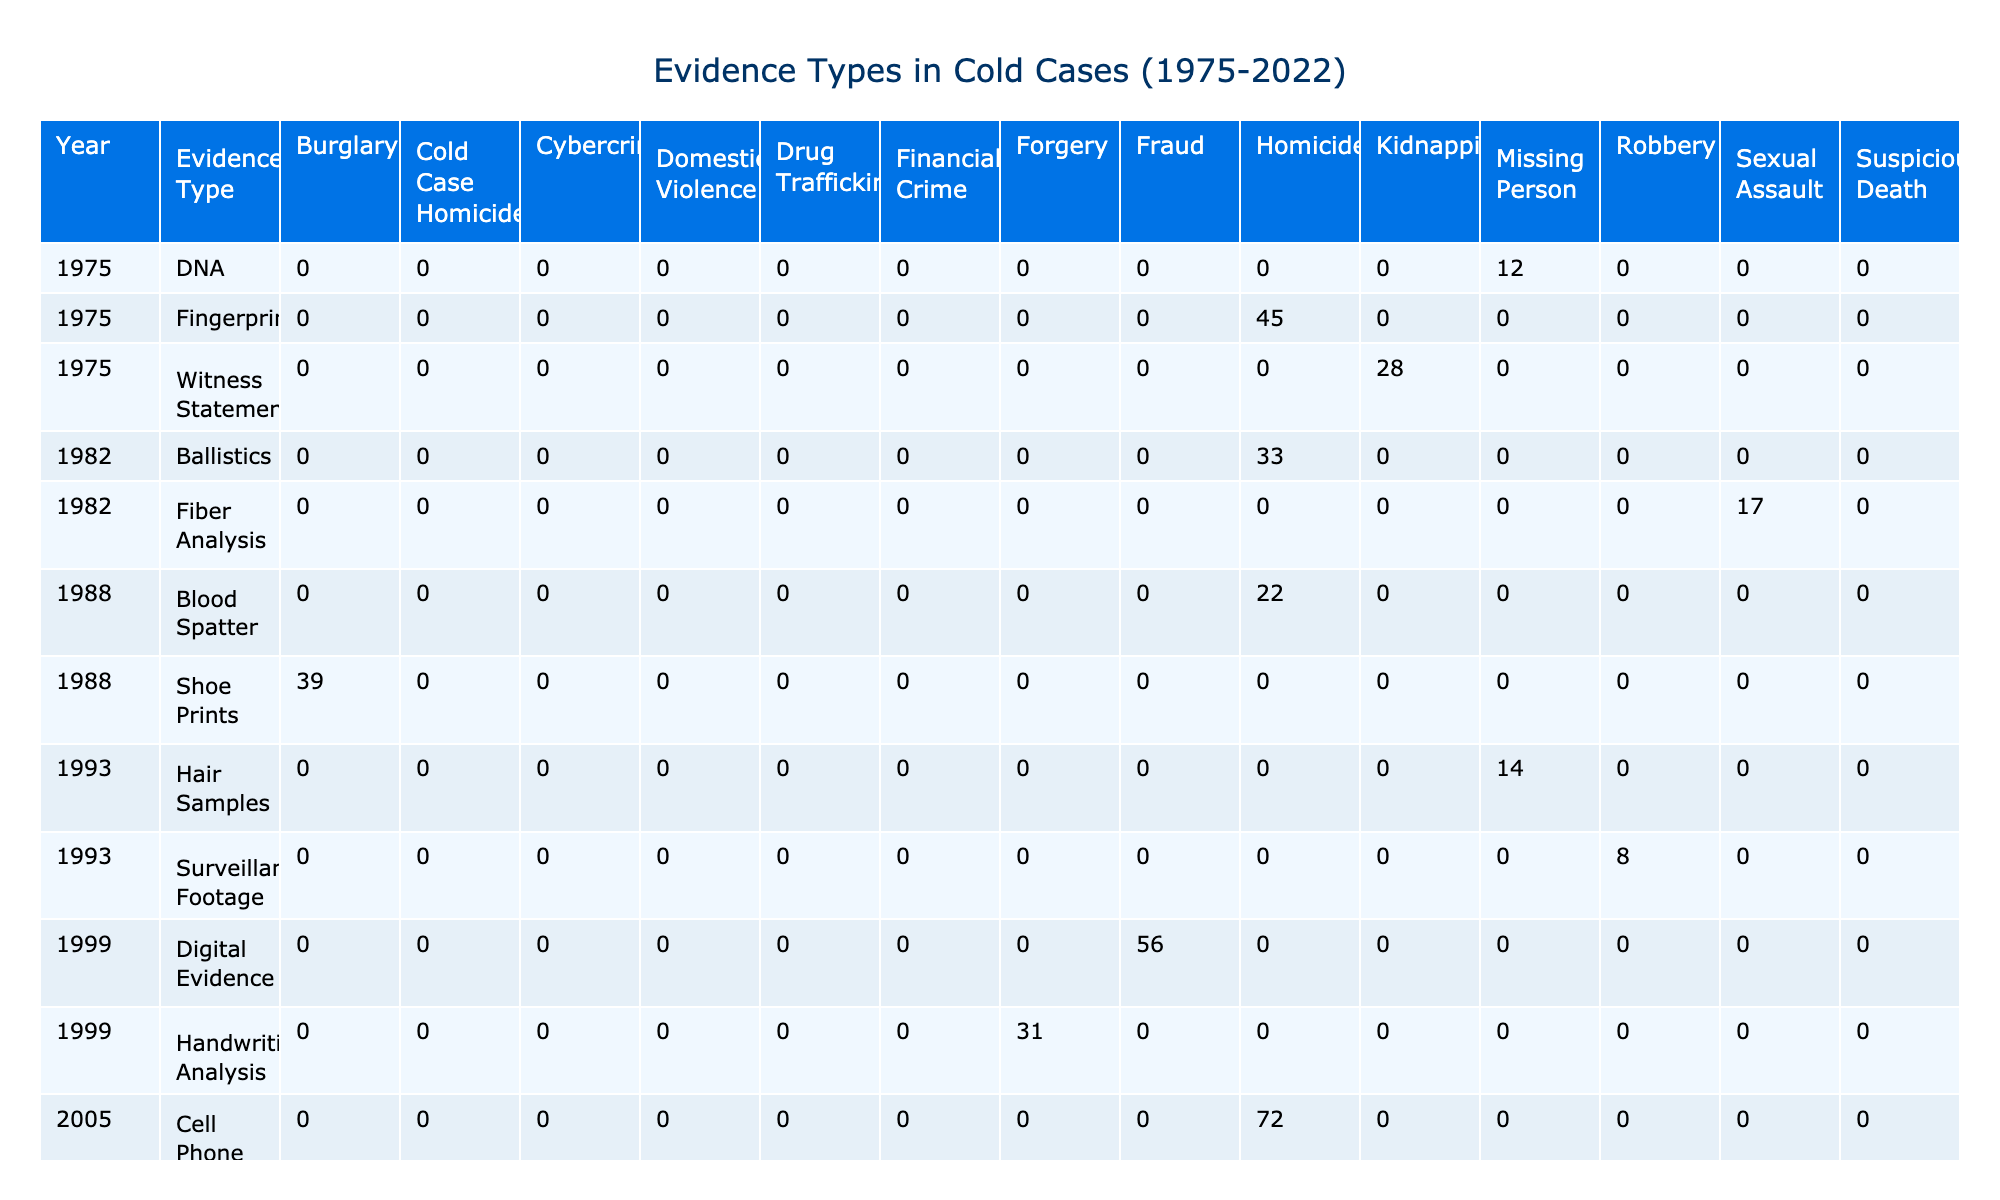What is the most common type of evidence collected in the year 2015? In 2015, the evidence type with the highest quantity is Computer Forensics, which has a quantity of 103.
Answer: Computer Forensics How many blood spatter evidence pieces were collected for homicide cases from 1988? The table shows that 22 blood spatter evidence pieces were collected for homicide cases in 1988.
Answer: 22 What is the average quantity of digital evidence collected in the years 1999 and 2015? The quantity of digital evidence in 1999 is 56, and in 2015 it is 103. To find the average, we sum them (56 + 103) = 159 and divide by 2. The average is 159/2 = 79.5.
Answer: 79.5 Did any cold case homicide evidence collect at least 30 items in 2020? In 2020, the evidence type Genetic Genealogy collected 37 items, which is more than 30, making the statement true.
Answer: Yes How many different types of evidence related to homicide cases can be found in the table? By examining the table, the evidence types related to homicide are Fingerprints, Ballistics, Blood Spatter, and Cell Phone Records. That's a total of 4 different types.
Answer: 4 How much DNA evidence was collected in the missing person cases compared to hair samples in 1993? In 1975, the quantity of DNA evidence collected for missing person cases was 12, while in 1993, the quantity of hair samples was 14. The difference is 14 - 12 = 2, indicating that more hair samples were collected.
Answer: 2 What is the total quantity of evidence collected for kidnapping cases between 1975 and 2022? From the table, the quantities for kidnapping cases are 28 (witness statements, 1975) + 26 (vehicle GPS data, 2010) = 54. So the total quantity of evidence for kidnapping cases is 54.
Answer: 54 Is it true that more than half of the collected evidence in missing person cases comes from the year 2010? In 2010, the evidence collected for missing person cases is 89, while the total for the years 1975 to 2022 is 12 (1975) + 14 (1993) + 89 (2010) = 115. Since 89 is more than half of 115, the statement is true.
Answer: Yes 